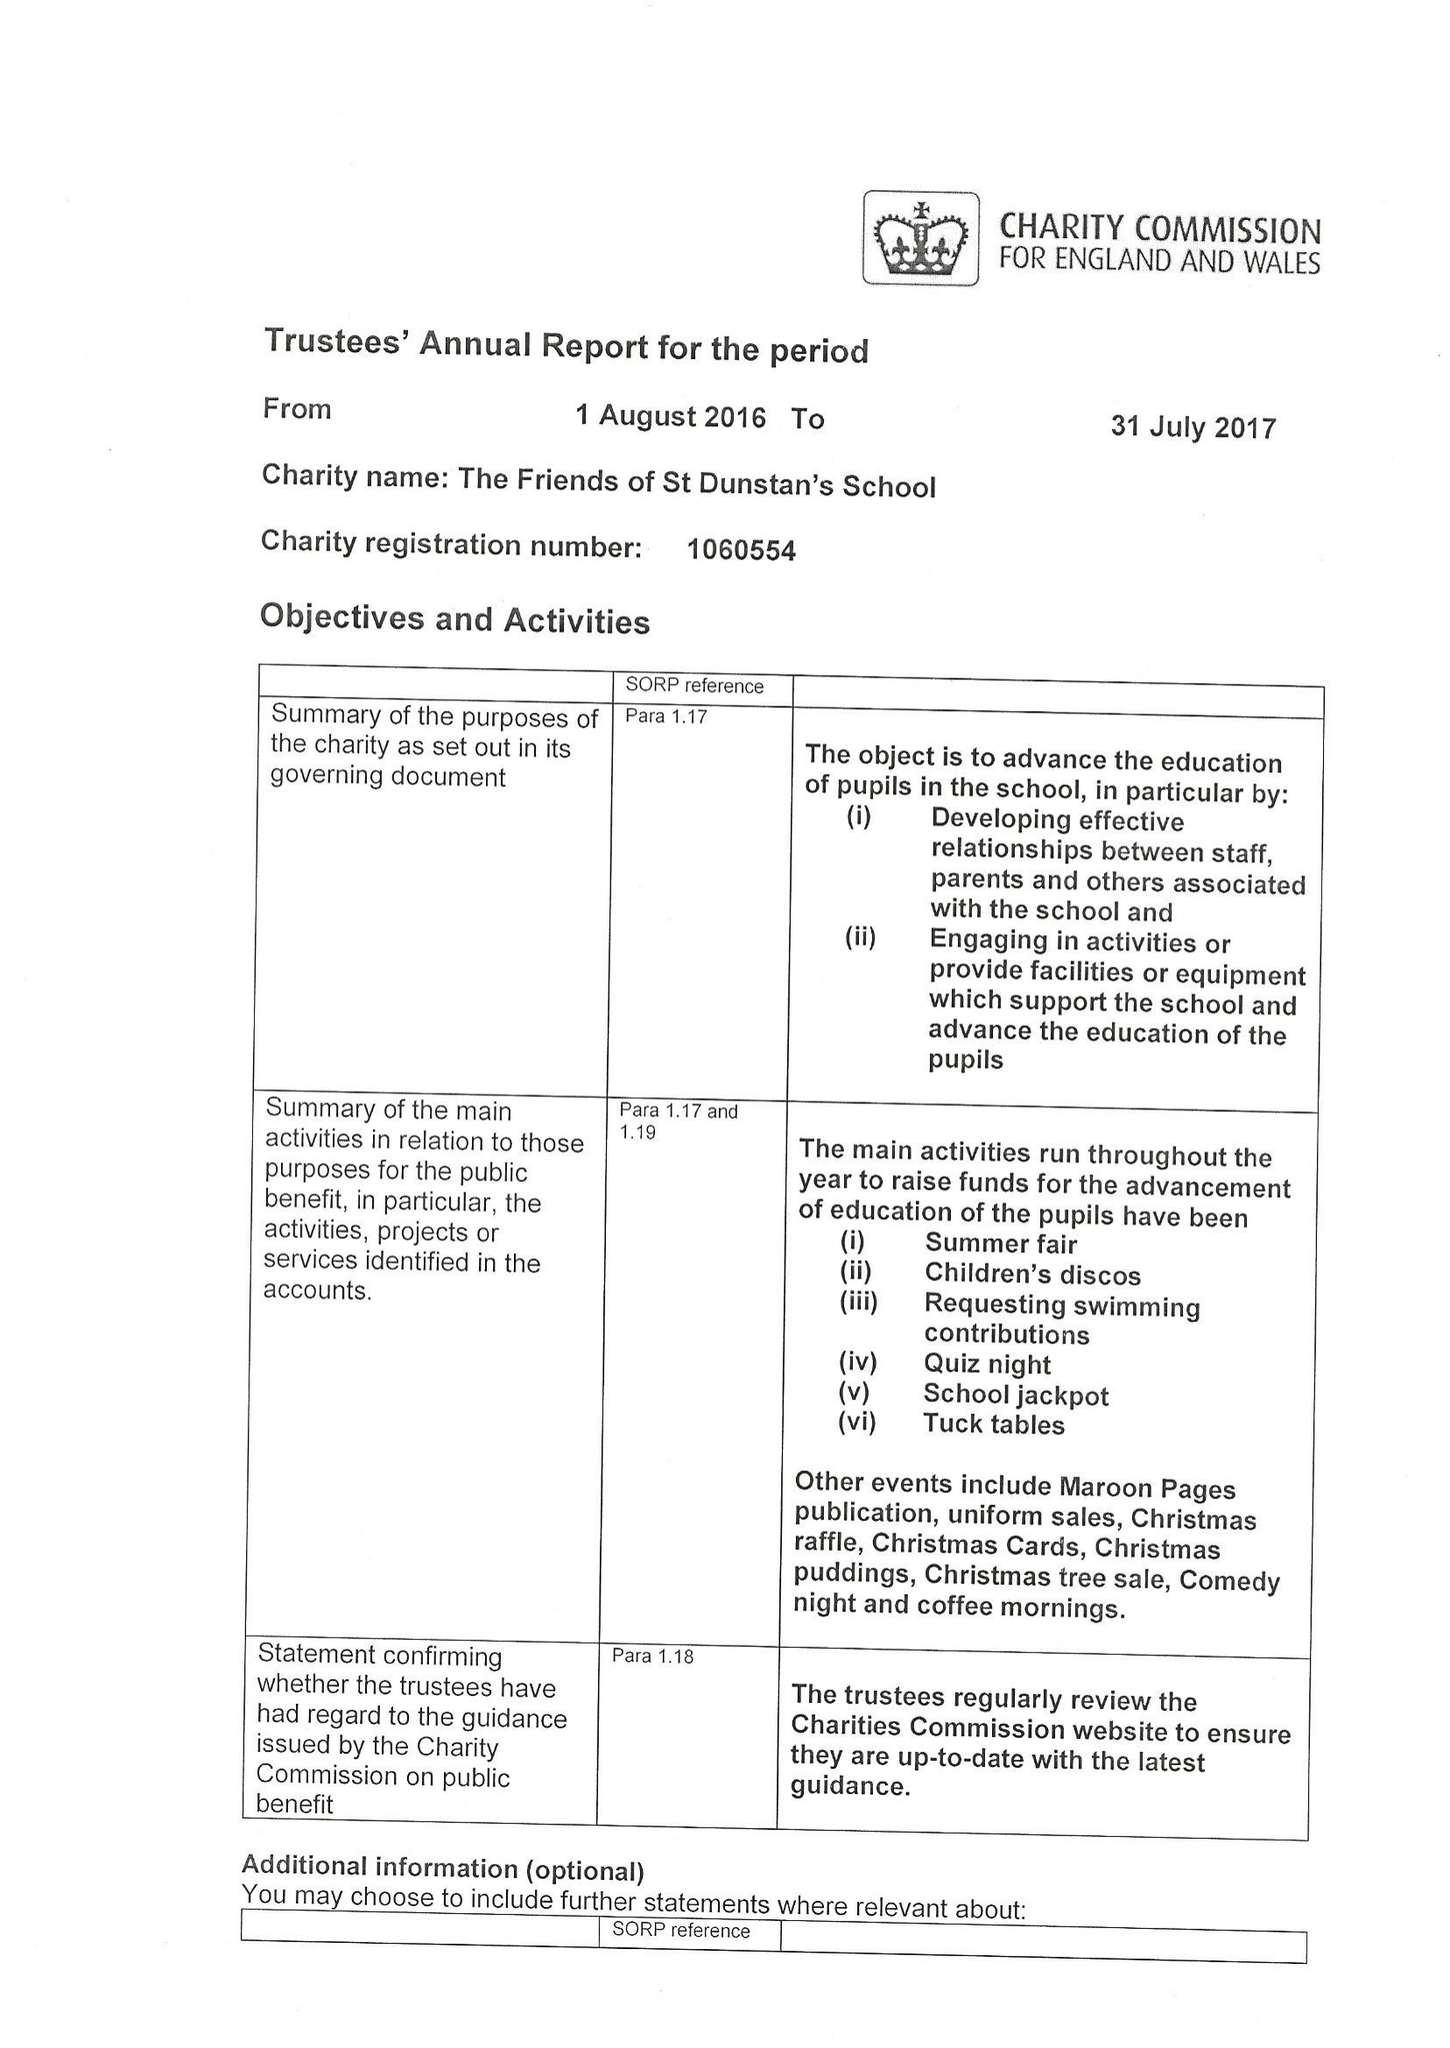What is the value for the address__post_town?
Answer the question using a single word or phrase. WOKING 